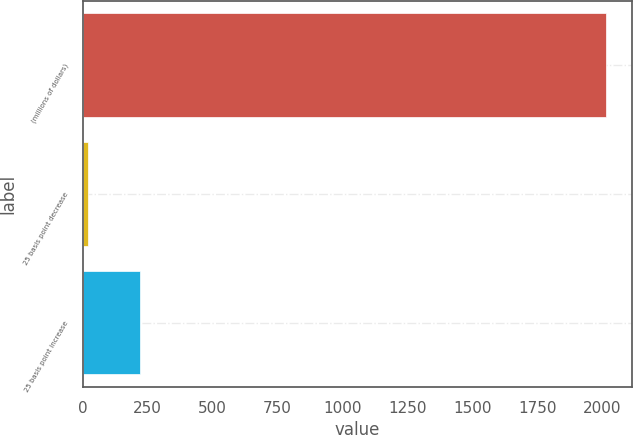<chart> <loc_0><loc_0><loc_500><loc_500><bar_chart><fcel>(millions of dollars)<fcel>25 basis point decrease<fcel>25 basis point increase<nl><fcel>2014<fcel>20.8<fcel>220.12<nl></chart> 